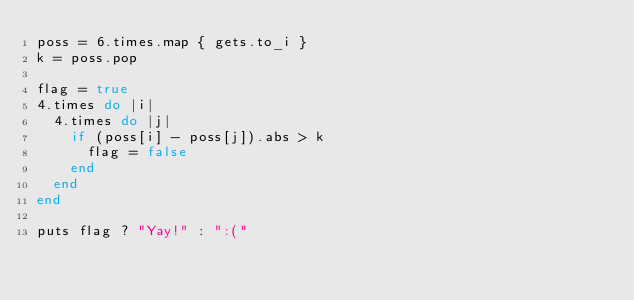Convert code to text. <code><loc_0><loc_0><loc_500><loc_500><_Ruby_>poss = 6.times.map { gets.to_i }
k = poss.pop

flag = true
4.times do |i|
	4.times do |j|
		if (poss[i] - poss[j]).abs > k
			flag = false
		end
	end
end

puts flag ? "Yay!" : ":("
</code> 